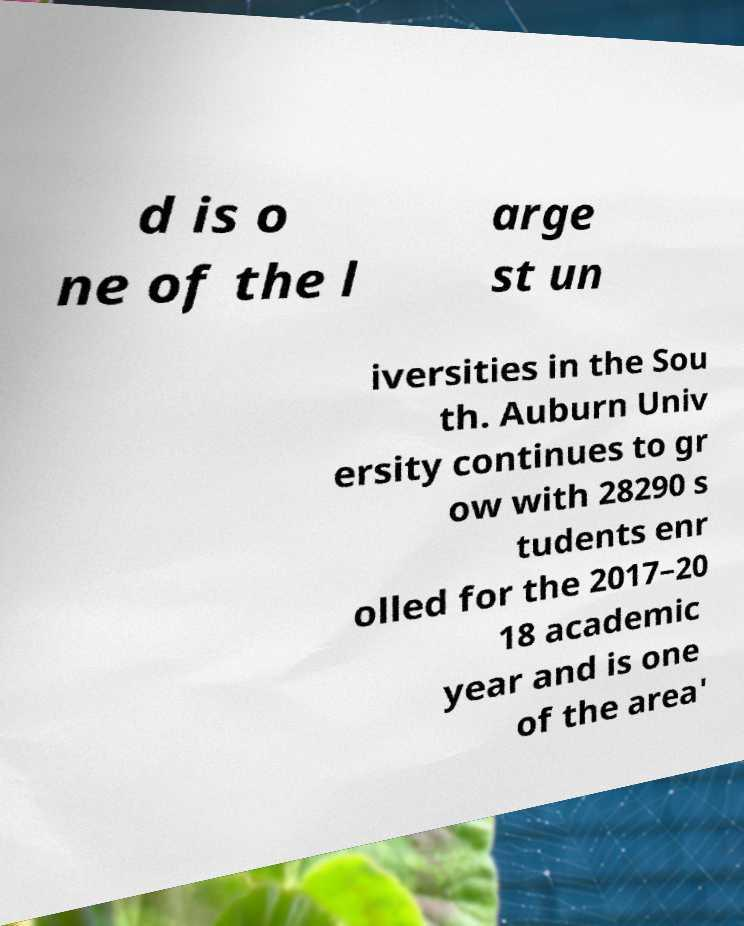There's text embedded in this image that I need extracted. Can you transcribe it verbatim? d is o ne of the l arge st un iversities in the Sou th. Auburn Univ ersity continues to gr ow with 28290 s tudents enr olled for the 2017–20 18 academic year and is one of the area' 